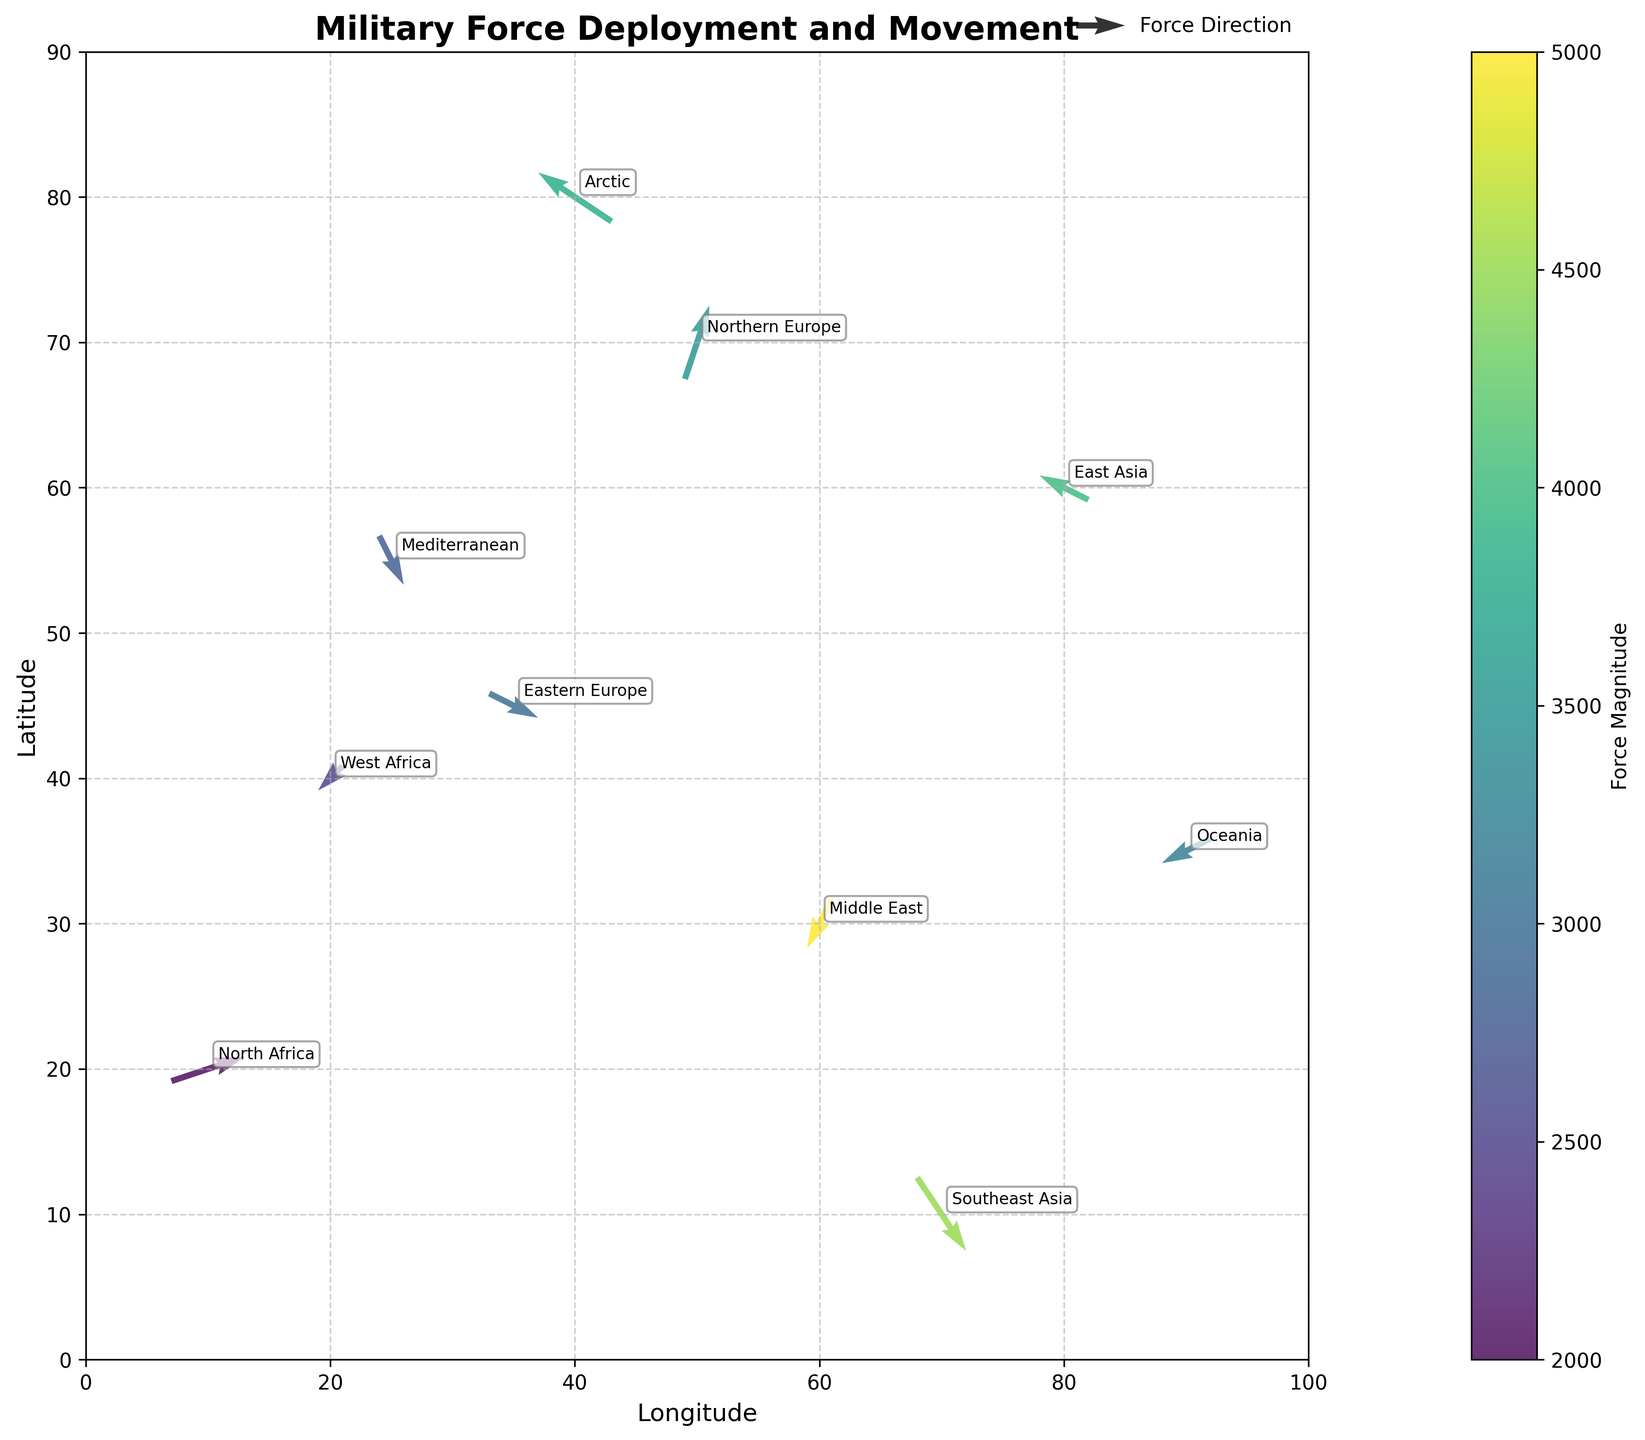what's the title of the figure? The title is displayed at the top of the figure; it summarizes the content of the plot. The title in this figure is "Military Force Deployment and Movement."
Answer: Military Force Deployment and Movement how many data points are plotted in the figure? Count the number of arrows in the quiver plot to determine the number of data points. There are 10 arrows in the plot.
Answer: 10 which region shows the highest force magnitude? The color intensity represents force magnitude. The darkest colored arrow corresponds to the highest magnitude. Here, the region "Southeast Asia" with a magnitude of 4500 has the darkest arrow.
Answer: Southeast Asia what are the longitude and latitude ranges displayed in the plot? The x-axis (longitude) ranges from 0 to 100, and the y-axis (latitude) ranges from 0 to 90 as indicated by the axis labels and grid limits.
Answer: Longitude: 0-100, Latitude: 0-90 which regions have forces moving southward? Forces moving southward will have a negative y-component (v). By examining the plot, the regions "Eastern Europe," "Middle East," "Mediterranean," and "Oceania" have arrows with a negative y-component.
Answer: Eastern Europe, Middle East, Mediterranean, Oceania what is the direction and magnitude of the force in Northern Europe? The arrow labeled "Northern Europe" indicates the direction of force. It is oriented from point (50, 70) to (51, 73) with components (u=1, v=3). The magnitude is labeled as 3500.
Answer: Direction: (1, 3), Magnitude: 3500 compare the force magnitudes of East Asia and Arctic. Which is higher? Look at the color intensity or directly read the magnitudes from the labels. "East Asia" has a magnitude of 4000, and "Arctic" is 3800. East Asia has the higher magnitude.
Answer: East Asia which region has the most westward moving force? The westward direction corresponds to a negative x-component (u). The region "Arctic" with u = -3 shows the most westward movement.
Answer: Arctic if you sum the magnitudes of forces in Africa (North Africa and West Africa), what is the total? North Africa has a magnitude of 2000 and West Africa has 2500. Summing these gives 2000 + 2500 = 4500.
Answer: 4500 what is the average force magnitude across all regions? Sum all the magnitudes and divide by the number of regions. Summing: 3000 + 5000 + 2000 + 4000 + 3500 + 2500 + 4500 + 3800 + 2800 + 3200 = 34300, average: 34300 / 10 = 3430.
Answer: 3430 